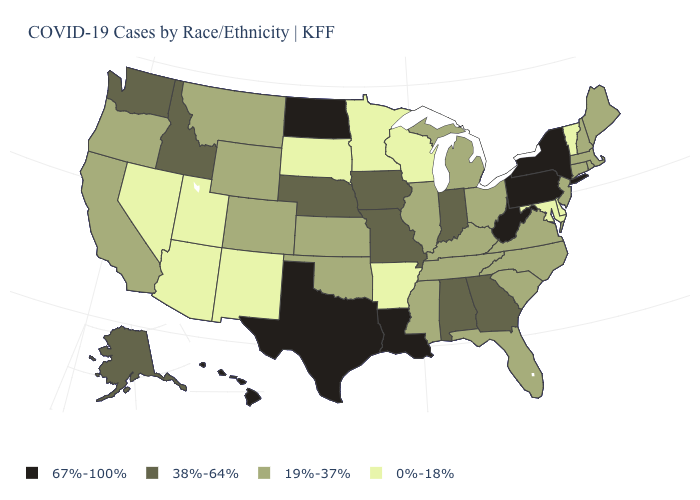Which states hav the highest value in the West?
Short answer required. Hawaii. Name the states that have a value in the range 19%-37%?
Write a very short answer. California, Colorado, Connecticut, Florida, Illinois, Kansas, Kentucky, Maine, Massachusetts, Michigan, Mississippi, Montana, New Hampshire, New Jersey, North Carolina, Ohio, Oklahoma, Oregon, Rhode Island, South Carolina, Tennessee, Virginia, Wyoming. Name the states that have a value in the range 0%-18%?
Short answer required. Arizona, Arkansas, Delaware, Maryland, Minnesota, Nevada, New Mexico, South Dakota, Utah, Vermont, Wisconsin. Among the states that border North Carolina , which have the highest value?
Be succinct. Georgia. Which states hav the highest value in the West?
Be succinct. Hawaii. What is the lowest value in states that border Virginia?
Be succinct. 0%-18%. Does the first symbol in the legend represent the smallest category?
Write a very short answer. No. Among the states that border Ohio , does Indiana have the highest value?
Concise answer only. No. Does the first symbol in the legend represent the smallest category?
Write a very short answer. No. What is the value of Connecticut?
Short answer required. 19%-37%. What is the lowest value in the USA?
Give a very brief answer. 0%-18%. What is the highest value in the USA?
Be succinct. 67%-100%. Is the legend a continuous bar?
Quick response, please. No. What is the value of Hawaii?
Answer briefly. 67%-100%. Name the states that have a value in the range 38%-64%?
Keep it brief. Alabama, Alaska, Georgia, Idaho, Indiana, Iowa, Missouri, Nebraska, Washington. 